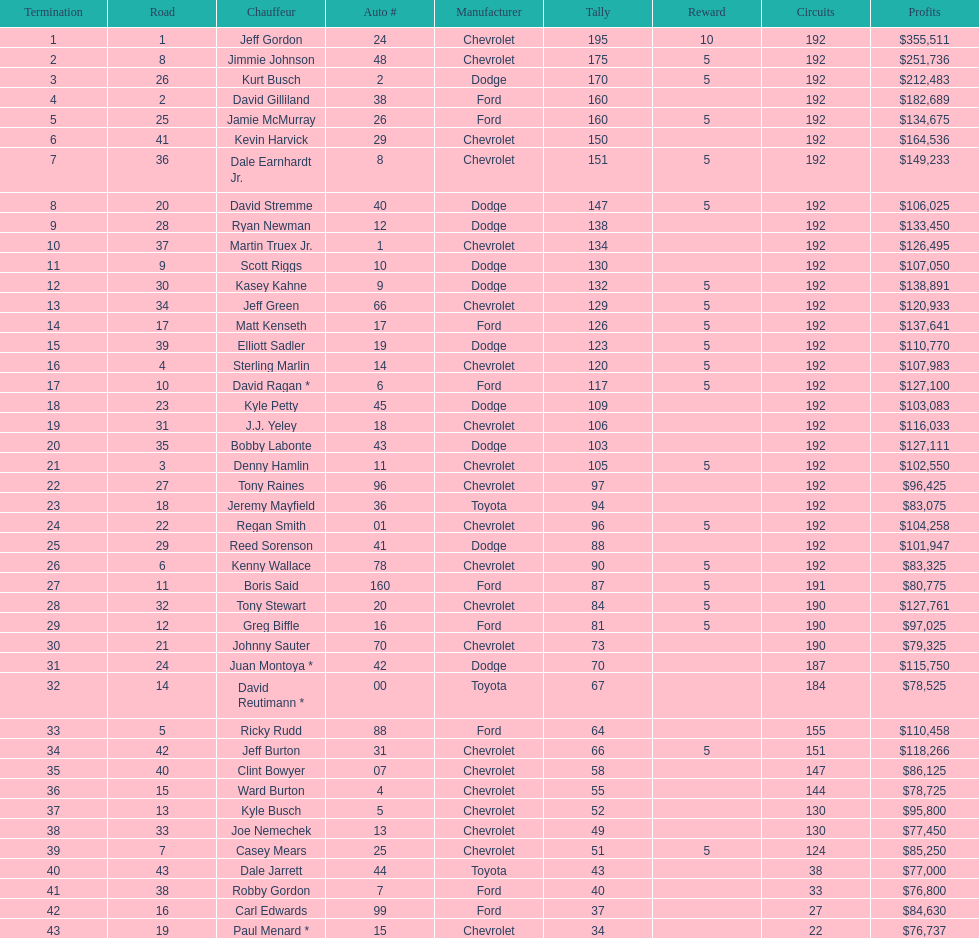Would you mind parsing the complete table? {'header': ['Termination', 'Road', 'Chauffeur', 'Auto #', 'Manufacturer', 'Tally', 'Reward', 'Circuits', 'Profits'], 'rows': [['1', '1', 'Jeff Gordon', '24', 'Chevrolet', '195', '10', '192', '$355,511'], ['2', '8', 'Jimmie Johnson', '48', 'Chevrolet', '175', '5', '192', '$251,736'], ['3', '26', 'Kurt Busch', '2', 'Dodge', '170', '5', '192', '$212,483'], ['4', '2', 'David Gilliland', '38', 'Ford', '160', '', '192', '$182,689'], ['5', '25', 'Jamie McMurray', '26', 'Ford', '160', '5', '192', '$134,675'], ['6', '41', 'Kevin Harvick', '29', 'Chevrolet', '150', '', '192', '$164,536'], ['7', '36', 'Dale Earnhardt Jr.', '8', 'Chevrolet', '151', '5', '192', '$149,233'], ['8', '20', 'David Stremme', '40', 'Dodge', '147', '5', '192', '$106,025'], ['9', '28', 'Ryan Newman', '12', 'Dodge', '138', '', '192', '$133,450'], ['10', '37', 'Martin Truex Jr.', '1', 'Chevrolet', '134', '', '192', '$126,495'], ['11', '9', 'Scott Riggs', '10', 'Dodge', '130', '', '192', '$107,050'], ['12', '30', 'Kasey Kahne', '9', 'Dodge', '132', '5', '192', '$138,891'], ['13', '34', 'Jeff Green', '66', 'Chevrolet', '129', '5', '192', '$120,933'], ['14', '17', 'Matt Kenseth', '17', 'Ford', '126', '5', '192', '$137,641'], ['15', '39', 'Elliott Sadler', '19', 'Dodge', '123', '5', '192', '$110,770'], ['16', '4', 'Sterling Marlin', '14', 'Chevrolet', '120', '5', '192', '$107,983'], ['17', '10', 'David Ragan *', '6', 'Ford', '117', '5', '192', '$127,100'], ['18', '23', 'Kyle Petty', '45', 'Dodge', '109', '', '192', '$103,083'], ['19', '31', 'J.J. Yeley', '18', 'Chevrolet', '106', '', '192', '$116,033'], ['20', '35', 'Bobby Labonte', '43', 'Dodge', '103', '', '192', '$127,111'], ['21', '3', 'Denny Hamlin', '11', 'Chevrolet', '105', '5', '192', '$102,550'], ['22', '27', 'Tony Raines', '96', 'Chevrolet', '97', '', '192', '$96,425'], ['23', '18', 'Jeremy Mayfield', '36', 'Toyota', '94', '', '192', '$83,075'], ['24', '22', 'Regan Smith', '01', 'Chevrolet', '96', '5', '192', '$104,258'], ['25', '29', 'Reed Sorenson', '41', 'Dodge', '88', '', '192', '$101,947'], ['26', '6', 'Kenny Wallace', '78', 'Chevrolet', '90', '5', '192', '$83,325'], ['27', '11', 'Boris Said', '160', 'Ford', '87', '5', '191', '$80,775'], ['28', '32', 'Tony Stewart', '20', 'Chevrolet', '84', '5', '190', '$127,761'], ['29', '12', 'Greg Biffle', '16', 'Ford', '81', '5', '190', '$97,025'], ['30', '21', 'Johnny Sauter', '70', 'Chevrolet', '73', '', '190', '$79,325'], ['31', '24', 'Juan Montoya *', '42', 'Dodge', '70', '', '187', '$115,750'], ['32', '14', 'David Reutimann *', '00', 'Toyota', '67', '', '184', '$78,525'], ['33', '5', 'Ricky Rudd', '88', 'Ford', '64', '', '155', '$110,458'], ['34', '42', 'Jeff Burton', '31', 'Chevrolet', '66', '5', '151', '$118,266'], ['35', '40', 'Clint Bowyer', '07', 'Chevrolet', '58', '', '147', '$86,125'], ['36', '15', 'Ward Burton', '4', 'Chevrolet', '55', '', '144', '$78,725'], ['37', '13', 'Kyle Busch', '5', 'Chevrolet', '52', '', '130', '$95,800'], ['38', '33', 'Joe Nemechek', '13', 'Chevrolet', '49', '', '130', '$77,450'], ['39', '7', 'Casey Mears', '25', 'Chevrolet', '51', '5', '124', '$85,250'], ['40', '43', 'Dale Jarrett', '44', 'Toyota', '43', '', '38', '$77,000'], ['41', '38', 'Robby Gordon', '7', 'Ford', '40', '', '33', '$76,800'], ['42', '16', 'Carl Edwards', '99', 'Ford', '37', '', '27', '$84,630'], ['43', '19', 'Paul Menard *', '15', 'Chevrolet', '34', '', '22', '$76,737']]} How many drivers earned 5 bonus each in the race? 19. 